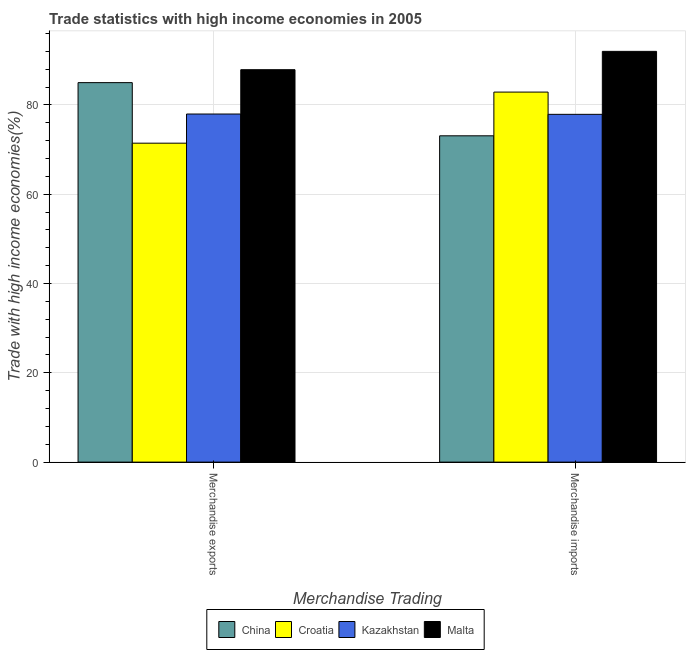How many different coloured bars are there?
Keep it short and to the point. 4. How many groups of bars are there?
Make the answer very short. 2. Are the number of bars per tick equal to the number of legend labels?
Your answer should be compact. Yes. What is the label of the 2nd group of bars from the left?
Keep it short and to the point. Merchandise imports. What is the merchandise exports in China?
Your response must be concise. 84.99. Across all countries, what is the maximum merchandise exports?
Keep it short and to the point. 87.89. Across all countries, what is the minimum merchandise exports?
Offer a terse response. 71.44. In which country was the merchandise imports maximum?
Keep it short and to the point. Malta. In which country was the merchandise imports minimum?
Offer a very short reply. China. What is the total merchandise exports in the graph?
Provide a short and direct response. 322.29. What is the difference between the merchandise imports in Malta and that in Kazakhstan?
Your response must be concise. 14.1. What is the difference between the merchandise imports in Malta and the merchandise exports in China?
Your answer should be compact. 7. What is the average merchandise exports per country?
Your answer should be compact. 80.57. What is the difference between the merchandise exports and merchandise imports in Croatia?
Keep it short and to the point. -11.44. In how many countries, is the merchandise exports greater than 84 %?
Offer a very short reply. 2. What is the ratio of the merchandise exports in Kazakhstan to that in Malta?
Ensure brevity in your answer.  0.89. Is the merchandise exports in China less than that in Croatia?
Your answer should be compact. No. In how many countries, is the merchandise exports greater than the average merchandise exports taken over all countries?
Provide a short and direct response. 2. What does the 2nd bar from the left in Merchandise imports represents?
Offer a very short reply. Croatia. What does the 2nd bar from the right in Merchandise imports represents?
Provide a succinct answer. Kazakhstan. How many bars are there?
Your answer should be compact. 8. How many countries are there in the graph?
Offer a very short reply. 4. Does the graph contain grids?
Your answer should be very brief. Yes. Where does the legend appear in the graph?
Your response must be concise. Bottom center. How many legend labels are there?
Offer a very short reply. 4. What is the title of the graph?
Give a very brief answer. Trade statistics with high income economies in 2005. Does "Samoa" appear as one of the legend labels in the graph?
Offer a very short reply. No. What is the label or title of the X-axis?
Your response must be concise. Merchandise Trading. What is the label or title of the Y-axis?
Give a very brief answer. Trade with high income economies(%). What is the Trade with high income economies(%) of China in Merchandise exports?
Provide a succinct answer. 84.99. What is the Trade with high income economies(%) of Croatia in Merchandise exports?
Your answer should be compact. 71.44. What is the Trade with high income economies(%) in Kazakhstan in Merchandise exports?
Offer a very short reply. 77.97. What is the Trade with high income economies(%) of Malta in Merchandise exports?
Your answer should be compact. 87.89. What is the Trade with high income economies(%) of China in Merchandise imports?
Keep it short and to the point. 73.09. What is the Trade with high income economies(%) in Croatia in Merchandise imports?
Your answer should be very brief. 82.88. What is the Trade with high income economies(%) in Kazakhstan in Merchandise imports?
Provide a succinct answer. 77.9. What is the Trade with high income economies(%) in Malta in Merchandise imports?
Keep it short and to the point. 92. Across all Merchandise Trading, what is the maximum Trade with high income economies(%) in China?
Your response must be concise. 84.99. Across all Merchandise Trading, what is the maximum Trade with high income economies(%) in Croatia?
Your response must be concise. 82.88. Across all Merchandise Trading, what is the maximum Trade with high income economies(%) of Kazakhstan?
Offer a very short reply. 77.97. Across all Merchandise Trading, what is the maximum Trade with high income economies(%) of Malta?
Offer a very short reply. 92. Across all Merchandise Trading, what is the minimum Trade with high income economies(%) in China?
Ensure brevity in your answer.  73.09. Across all Merchandise Trading, what is the minimum Trade with high income economies(%) of Croatia?
Offer a very short reply. 71.44. Across all Merchandise Trading, what is the minimum Trade with high income economies(%) of Kazakhstan?
Make the answer very short. 77.9. Across all Merchandise Trading, what is the minimum Trade with high income economies(%) of Malta?
Ensure brevity in your answer.  87.89. What is the total Trade with high income economies(%) of China in the graph?
Make the answer very short. 158.08. What is the total Trade with high income economies(%) of Croatia in the graph?
Offer a terse response. 154.32. What is the total Trade with high income economies(%) of Kazakhstan in the graph?
Make the answer very short. 155.86. What is the total Trade with high income economies(%) of Malta in the graph?
Offer a terse response. 179.89. What is the difference between the Trade with high income economies(%) in China in Merchandise exports and that in Merchandise imports?
Your response must be concise. 11.91. What is the difference between the Trade with high income economies(%) in Croatia in Merchandise exports and that in Merchandise imports?
Your answer should be compact. -11.45. What is the difference between the Trade with high income economies(%) of Kazakhstan in Merchandise exports and that in Merchandise imports?
Provide a succinct answer. 0.07. What is the difference between the Trade with high income economies(%) of Malta in Merchandise exports and that in Merchandise imports?
Your answer should be compact. -4.11. What is the difference between the Trade with high income economies(%) of China in Merchandise exports and the Trade with high income economies(%) of Croatia in Merchandise imports?
Your response must be concise. 2.11. What is the difference between the Trade with high income economies(%) of China in Merchandise exports and the Trade with high income economies(%) of Kazakhstan in Merchandise imports?
Make the answer very short. 7.1. What is the difference between the Trade with high income economies(%) in China in Merchandise exports and the Trade with high income economies(%) in Malta in Merchandise imports?
Offer a very short reply. -7. What is the difference between the Trade with high income economies(%) in Croatia in Merchandise exports and the Trade with high income economies(%) in Kazakhstan in Merchandise imports?
Offer a very short reply. -6.46. What is the difference between the Trade with high income economies(%) of Croatia in Merchandise exports and the Trade with high income economies(%) of Malta in Merchandise imports?
Your response must be concise. -20.56. What is the difference between the Trade with high income economies(%) in Kazakhstan in Merchandise exports and the Trade with high income economies(%) in Malta in Merchandise imports?
Your response must be concise. -14.03. What is the average Trade with high income economies(%) in China per Merchandise Trading?
Keep it short and to the point. 79.04. What is the average Trade with high income economies(%) in Croatia per Merchandise Trading?
Your answer should be very brief. 77.16. What is the average Trade with high income economies(%) of Kazakhstan per Merchandise Trading?
Your answer should be compact. 77.93. What is the average Trade with high income economies(%) of Malta per Merchandise Trading?
Provide a short and direct response. 89.95. What is the difference between the Trade with high income economies(%) of China and Trade with high income economies(%) of Croatia in Merchandise exports?
Ensure brevity in your answer.  13.56. What is the difference between the Trade with high income economies(%) in China and Trade with high income economies(%) in Kazakhstan in Merchandise exports?
Offer a terse response. 7.03. What is the difference between the Trade with high income economies(%) of China and Trade with high income economies(%) of Malta in Merchandise exports?
Your response must be concise. -2.9. What is the difference between the Trade with high income economies(%) of Croatia and Trade with high income economies(%) of Kazakhstan in Merchandise exports?
Provide a succinct answer. -6.53. What is the difference between the Trade with high income economies(%) in Croatia and Trade with high income economies(%) in Malta in Merchandise exports?
Offer a very short reply. -16.46. What is the difference between the Trade with high income economies(%) of Kazakhstan and Trade with high income economies(%) of Malta in Merchandise exports?
Provide a succinct answer. -9.93. What is the difference between the Trade with high income economies(%) of China and Trade with high income economies(%) of Croatia in Merchandise imports?
Your answer should be compact. -9.79. What is the difference between the Trade with high income economies(%) in China and Trade with high income economies(%) in Kazakhstan in Merchandise imports?
Provide a succinct answer. -4.81. What is the difference between the Trade with high income economies(%) of China and Trade with high income economies(%) of Malta in Merchandise imports?
Ensure brevity in your answer.  -18.91. What is the difference between the Trade with high income economies(%) of Croatia and Trade with high income economies(%) of Kazakhstan in Merchandise imports?
Ensure brevity in your answer.  4.98. What is the difference between the Trade with high income economies(%) of Croatia and Trade with high income economies(%) of Malta in Merchandise imports?
Keep it short and to the point. -9.12. What is the difference between the Trade with high income economies(%) of Kazakhstan and Trade with high income economies(%) of Malta in Merchandise imports?
Make the answer very short. -14.1. What is the ratio of the Trade with high income economies(%) in China in Merchandise exports to that in Merchandise imports?
Your answer should be very brief. 1.16. What is the ratio of the Trade with high income economies(%) in Croatia in Merchandise exports to that in Merchandise imports?
Make the answer very short. 0.86. What is the ratio of the Trade with high income economies(%) of Malta in Merchandise exports to that in Merchandise imports?
Offer a terse response. 0.96. What is the difference between the highest and the second highest Trade with high income economies(%) of China?
Provide a succinct answer. 11.91. What is the difference between the highest and the second highest Trade with high income economies(%) of Croatia?
Provide a succinct answer. 11.45. What is the difference between the highest and the second highest Trade with high income economies(%) in Kazakhstan?
Offer a terse response. 0.07. What is the difference between the highest and the second highest Trade with high income economies(%) of Malta?
Ensure brevity in your answer.  4.11. What is the difference between the highest and the lowest Trade with high income economies(%) in China?
Your answer should be very brief. 11.91. What is the difference between the highest and the lowest Trade with high income economies(%) of Croatia?
Provide a succinct answer. 11.45. What is the difference between the highest and the lowest Trade with high income economies(%) of Kazakhstan?
Offer a terse response. 0.07. What is the difference between the highest and the lowest Trade with high income economies(%) of Malta?
Make the answer very short. 4.11. 